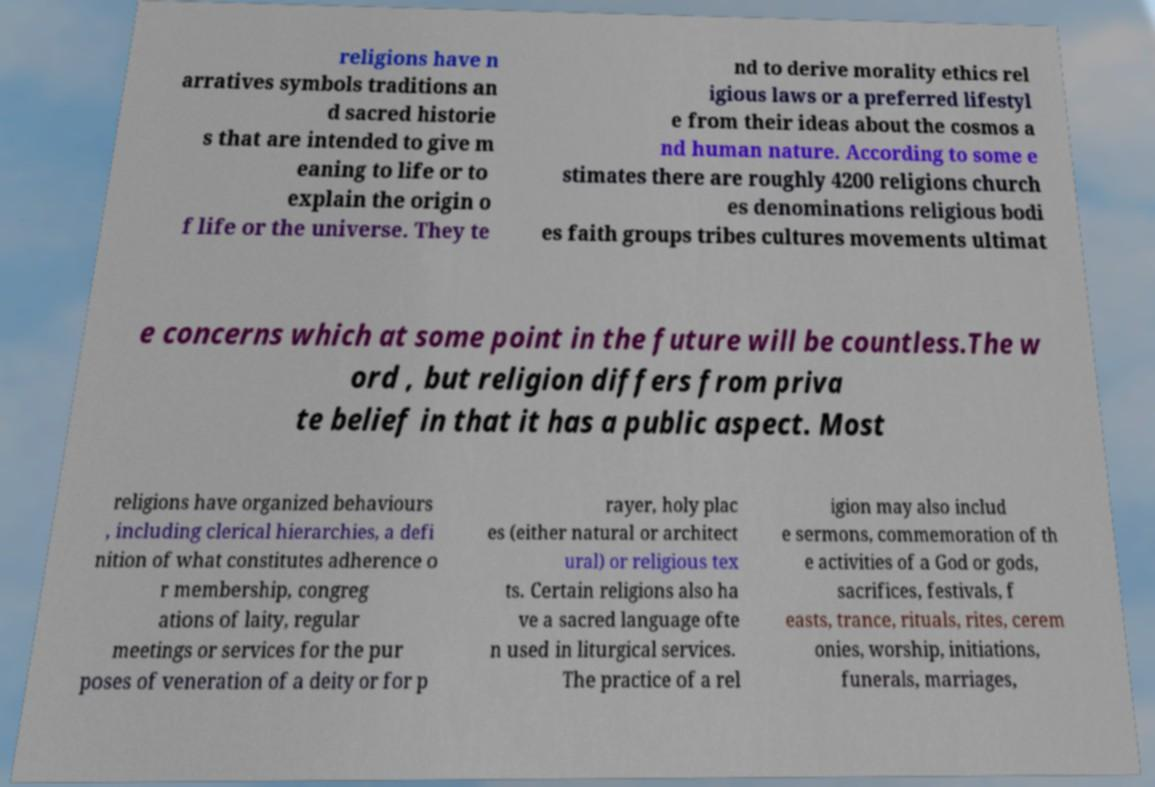Could you extract and type out the text from this image? religions have n arratives symbols traditions an d sacred historie s that are intended to give m eaning to life or to explain the origin o f life or the universe. They te nd to derive morality ethics rel igious laws or a preferred lifestyl e from their ideas about the cosmos a nd human nature. According to some e stimates there are roughly 4200 religions church es denominations religious bodi es faith groups tribes cultures movements ultimat e concerns which at some point in the future will be countless.The w ord , but religion differs from priva te belief in that it has a public aspect. Most religions have organized behaviours , including clerical hierarchies, a defi nition of what constitutes adherence o r membership, congreg ations of laity, regular meetings or services for the pur poses of veneration of a deity or for p rayer, holy plac es (either natural or architect ural) or religious tex ts. Certain religions also ha ve a sacred language ofte n used in liturgical services. The practice of a rel igion may also includ e sermons, commemoration of th e activities of a God or gods, sacrifices, festivals, f easts, trance, rituals, rites, cerem onies, worship, initiations, funerals, marriages, 